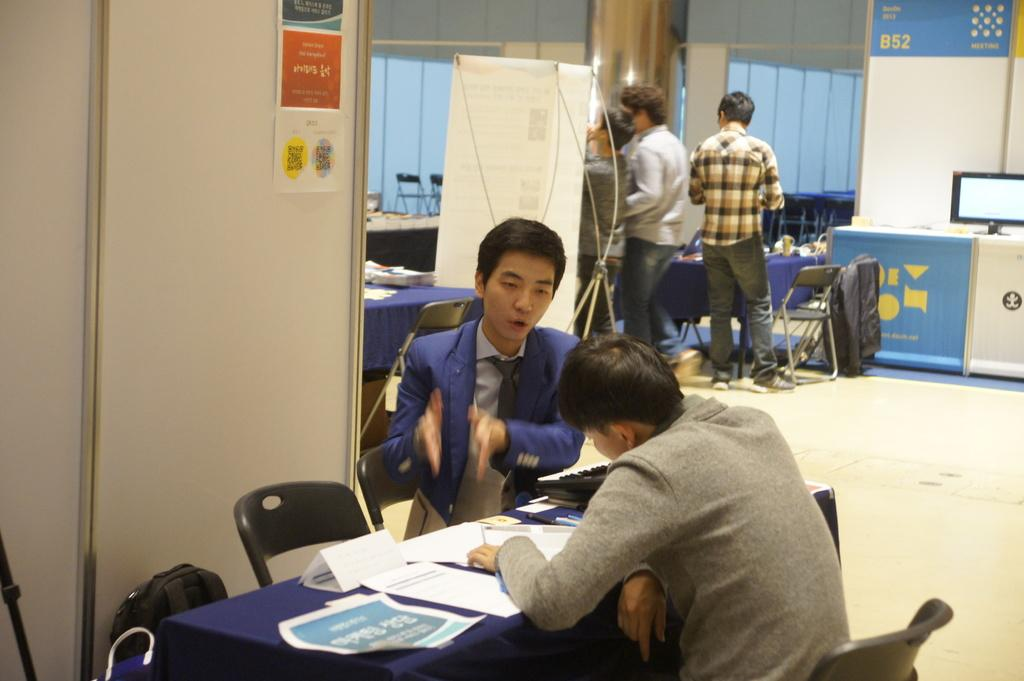Where was the image taken? The image was taken inside a room. What furniture is present in the room? There are tables and chairs in the room. What are the people in the room doing? Some people are sitting on the chairs, while others are standing. What electronic devices are in the room? There are computers in the room. What items can be seen on the tables? There are papers on the tables. Can you hear the people laughing in the image? The image is a still photograph, so there is no sound or laughter present. Is there a cemetery visible in the image? No, there is no cemetery present in the image; it is taken inside a room with tables, chairs, computers, and papers. 